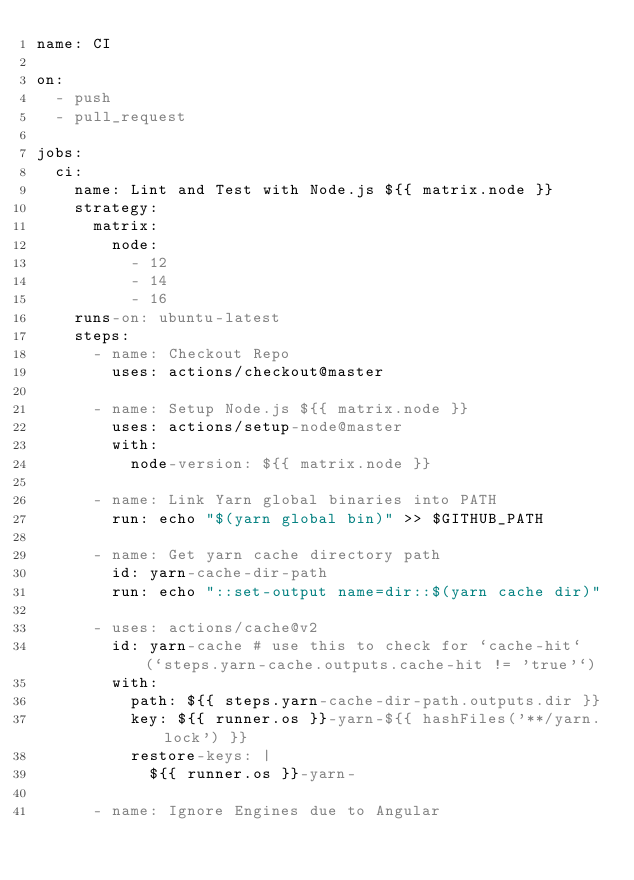<code> <loc_0><loc_0><loc_500><loc_500><_YAML_>name: CI

on:
  - push
  - pull_request

jobs:
  ci:
    name: Lint and Test with Node.js ${{ matrix.node }}
    strategy:
      matrix:
        node:
          - 12
          - 14
          - 16
    runs-on: ubuntu-latest
    steps:
      - name: Checkout Repo
        uses: actions/checkout@master

      - name: Setup Node.js ${{ matrix.node }}
        uses: actions/setup-node@master
        with:
          node-version: ${{ matrix.node }}

      - name: Link Yarn global binaries into PATH
        run: echo "$(yarn global bin)" >> $GITHUB_PATH

      - name: Get yarn cache directory path
        id: yarn-cache-dir-path
        run: echo "::set-output name=dir::$(yarn cache dir)"

      - uses: actions/cache@v2
        id: yarn-cache # use this to check for `cache-hit` (`steps.yarn-cache.outputs.cache-hit != 'true'`)
        with:
          path: ${{ steps.yarn-cache-dir-path.outputs.dir }}
          key: ${{ runner.os }}-yarn-${{ hashFiles('**/yarn.lock') }}
          restore-keys: |
            ${{ runner.os }}-yarn-

      - name: Ignore Engines due to Angular</code> 